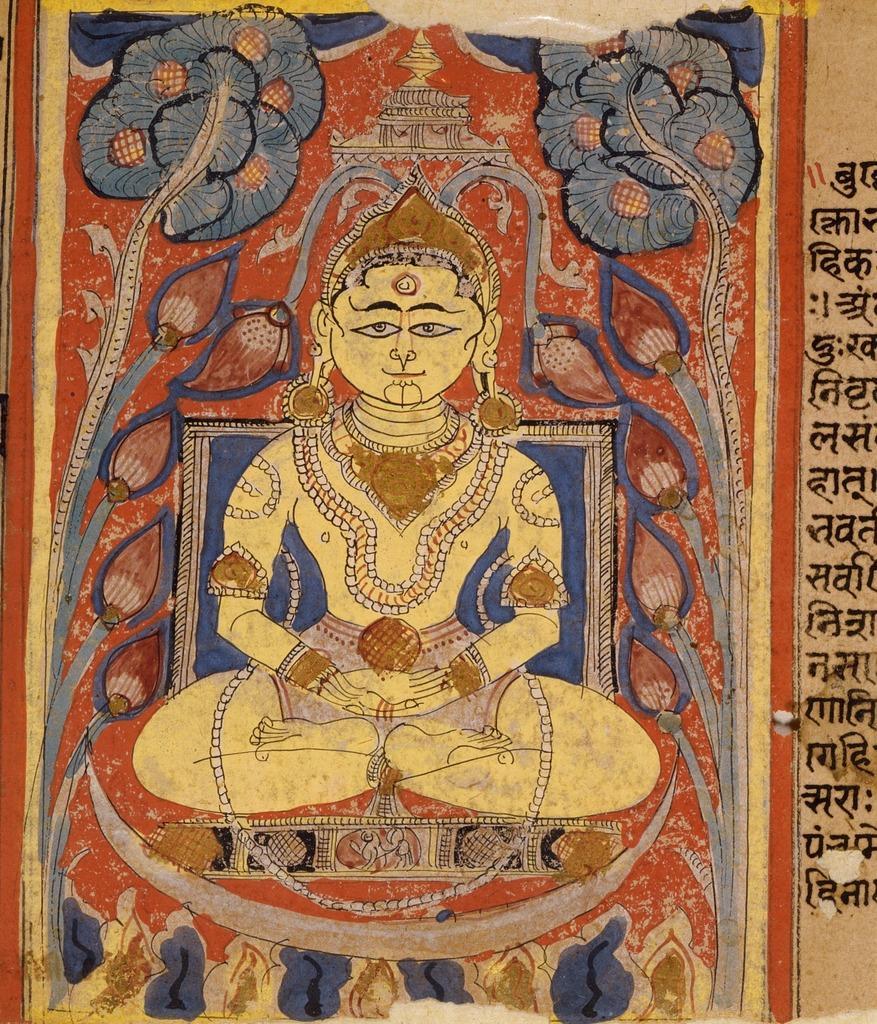In one or two sentences, can you explain what this image depicts? In the image we can see a painting of a person sitting and the person is wearing a neck chain, earrings, bracelet and a crown. This is a text and some design. 